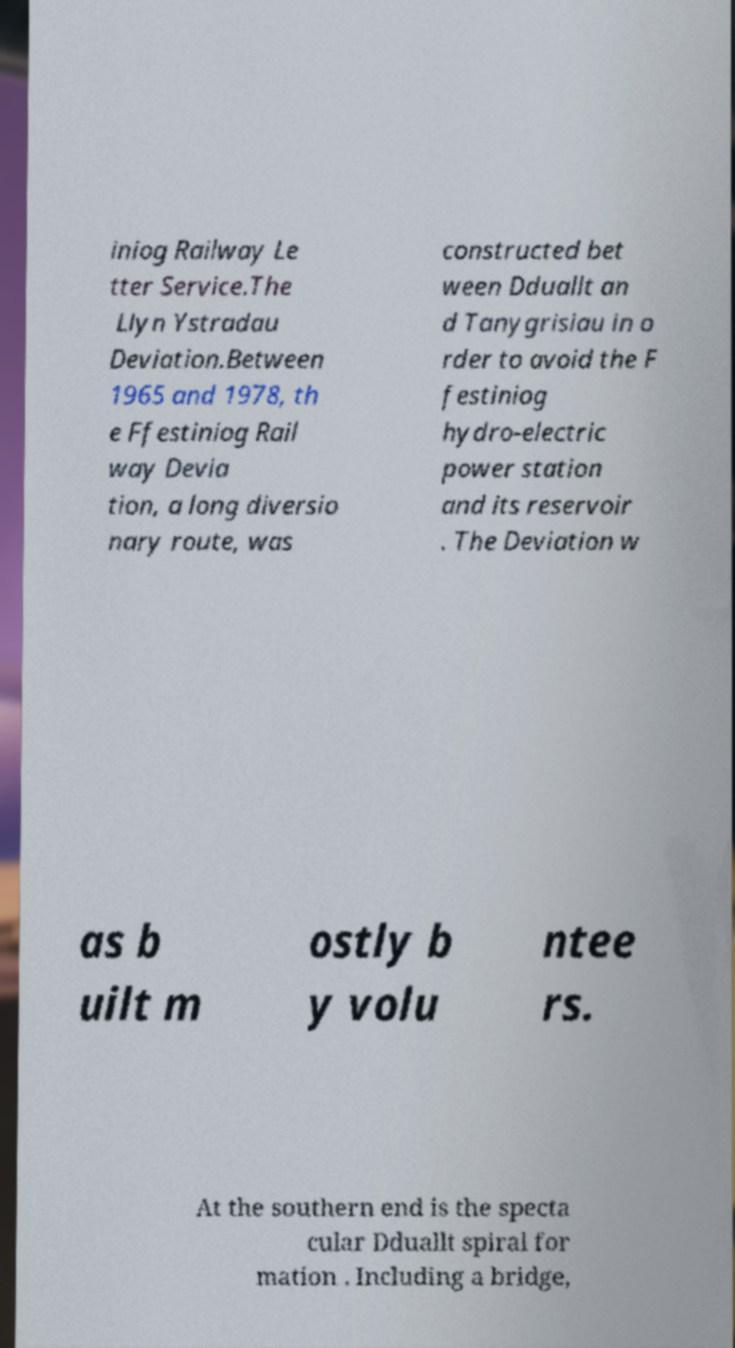What messages or text are displayed in this image? I need them in a readable, typed format. iniog Railway Le tter Service.The Llyn Ystradau Deviation.Between 1965 and 1978, th e Ffestiniog Rail way Devia tion, a long diversio nary route, was constructed bet ween Dduallt an d Tanygrisiau in o rder to avoid the F festiniog hydro-electric power station and its reservoir . The Deviation w as b uilt m ostly b y volu ntee rs. At the southern end is the specta cular Dduallt spiral for mation . Including a bridge, 